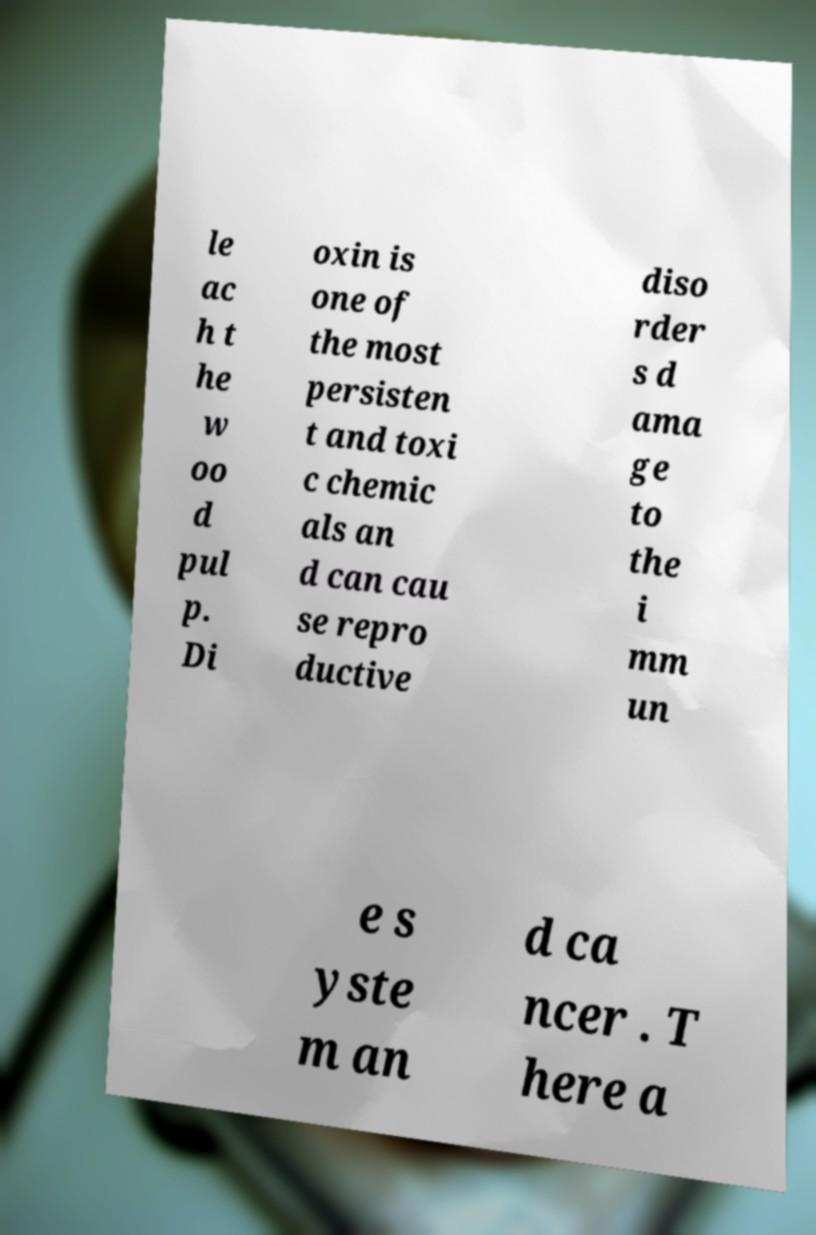Please identify and transcribe the text found in this image. le ac h t he w oo d pul p. Di oxin is one of the most persisten t and toxi c chemic als an d can cau se repro ductive diso rder s d ama ge to the i mm un e s yste m an d ca ncer . T here a 